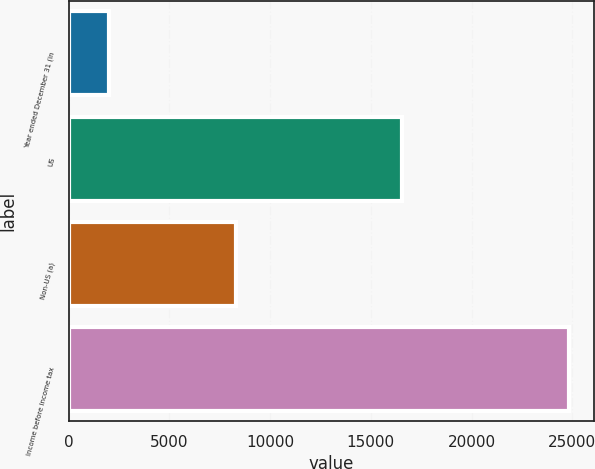Convert chart to OTSL. <chart><loc_0><loc_0><loc_500><loc_500><bar_chart><fcel>Year ended December 31 (in<fcel>US<fcel>Non-US (a)<fcel>Income before income tax<nl><fcel>2010<fcel>16568<fcel>8291<fcel>24859<nl></chart> 